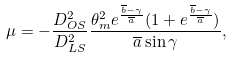Convert formula to latex. <formula><loc_0><loc_0><loc_500><loc_500>\mu = - \frac { D _ { O S } ^ { 2 } } { D _ { L S } ^ { 2 } } \frac { \theta _ { m } ^ { 2 } e ^ { \frac { \overline { b } - \gamma } { \overline { a } } } ( 1 + e ^ { \frac { \overline { b } - \gamma } { \overline { a } } } ) } { \overline { a } \sin \gamma } ,</formula> 